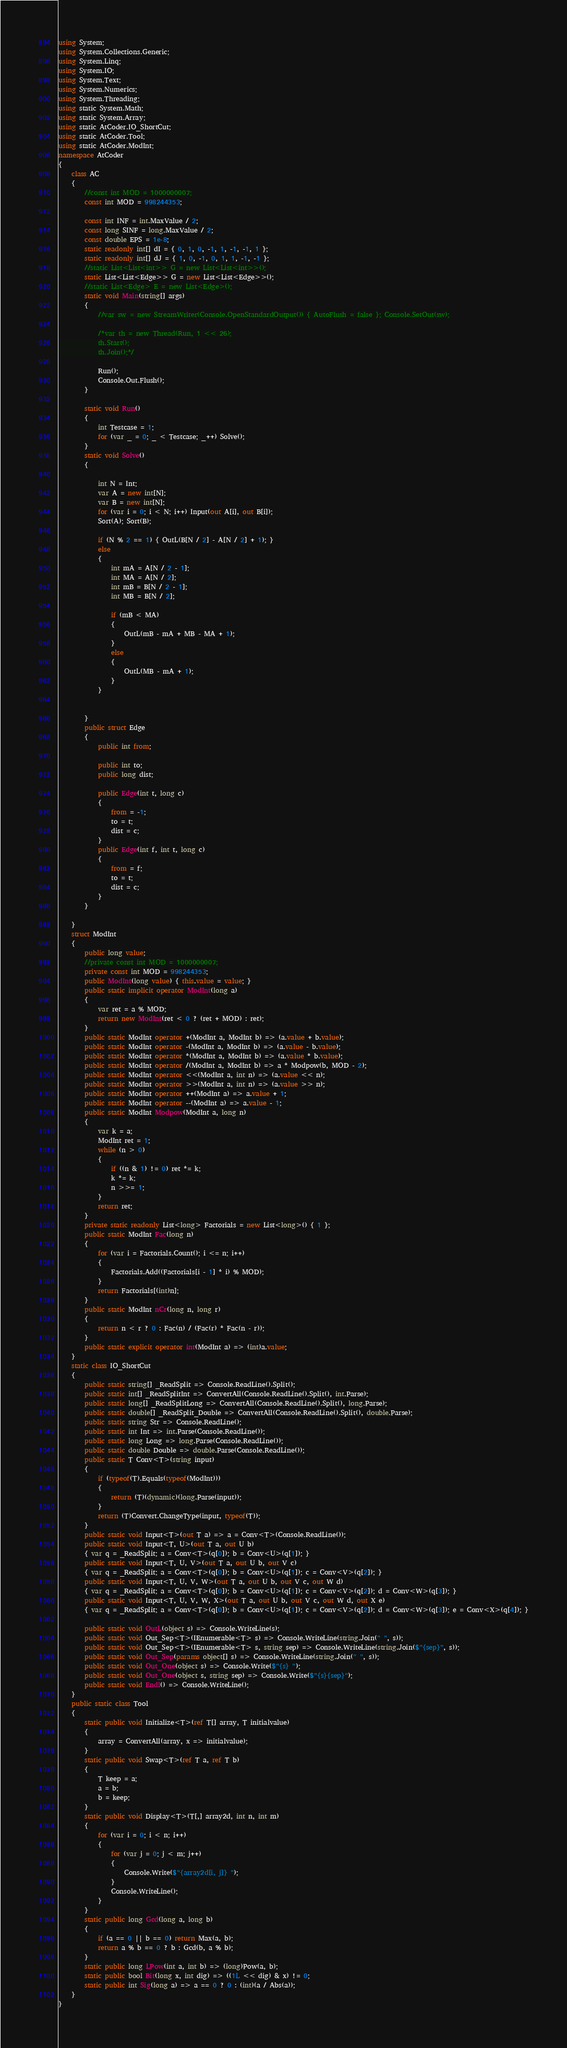<code> <loc_0><loc_0><loc_500><loc_500><_C#_>using System;
using System.Collections.Generic;
using System.Linq;
using System.IO;
using System.Text;
using System.Numerics;
using System.Threading;
using static System.Math;
using static System.Array;
using static AtCoder.IO_ShortCut;
using static AtCoder.Tool;
using static AtCoder.ModInt;
namespace AtCoder
{
    class AC
    {
        //const int MOD = 1000000007;
        const int MOD = 998244353;

        const int INF = int.MaxValue / 2;
        const long SINF = long.MaxValue / 2;
        const double EPS = 1e-8;
        static readonly int[] dI = { 0, 1, 0, -1, 1, -1, -1, 1 };
        static readonly int[] dJ = { 1, 0, -1, 0, 1, 1, -1, -1 };
        //static List<List<int>> G = new List<List<int>>();
        static List<List<Edge>> G = new List<List<Edge>>();
        //static List<Edge> E = new List<Edge>();
        static void Main(string[] args)
        {
            //var sw = new StreamWriter(Console.OpenStandardOutput()) { AutoFlush = false }; Console.SetOut(sw);

            /*var th = new Thread(Run, 1 << 26);
            th.Start();
            th.Join();*/

            Run();
            Console.Out.Flush();
        }

        static void Run()
        {
            int Testcase = 1;
            for (var _ = 0; _ < Testcase; _++) Solve();
        }
        static void Solve()
        {

            int N = Int;
            var A = new int[N];
            var B = new int[N];
            for (var i = 0; i < N; i++) Input(out A[i], out B[i]);
            Sort(A); Sort(B);

            if (N % 2 == 1) { OutL(B[N / 2] - A[N / 2] + 1); }
            else
            {
                int mA = A[N / 2 - 1];
                int MA = A[N / 2];
                int mB = B[N / 2 - 1];
                int MB = B[N / 2];

                if (mB < MA)
                {
                    OutL(mB - mA + MB - MA + 1);
                }
                else
                {
                    OutL(MB - mA + 1);
                }
            }


        }
        public struct Edge
        {
            public int from;

            public int to;
            public long dist;

            public Edge(int t, long c)
            {
                from = -1;
                to = t;
                dist = c;
            }
            public Edge(int f, int t, long c)
            {
                from = f;
                to = t;
                dist = c;
            }
        }
        
    }
    struct ModInt
    {
        public long value;
        //private const int MOD = 1000000007;
        private const int MOD = 998244353;
        public ModInt(long value) { this.value = value; }
        public static implicit operator ModInt(long a)
        {
            var ret = a % MOD;
            return new ModInt(ret < 0 ? (ret + MOD) : ret);
        }
        public static ModInt operator +(ModInt a, ModInt b) => (a.value + b.value);
        public static ModInt operator -(ModInt a, ModInt b) => (a.value - b.value);
        public static ModInt operator *(ModInt a, ModInt b) => (a.value * b.value);
        public static ModInt operator /(ModInt a, ModInt b) => a * Modpow(b, MOD - 2);
        public static ModInt operator <<(ModInt a, int n) => (a.value << n);
        public static ModInt operator >>(ModInt a, int n) => (a.value >> n);
        public static ModInt operator ++(ModInt a) => a.value + 1;
        public static ModInt operator --(ModInt a) => a.value - 1;
        public static ModInt Modpow(ModInt a, long n)
        {
            var k = a;
            ModInt ret = 1;
            while (n > 0)
            {
                if ((n & 1) != 0) ret *= k;
                k *= k;
                n >>= 1;
            }
            return ret;
        }
        private static readonly List<long> Factorials = new List<long>() { 1 };
        public static ModInt Fac(long n)
        {
            for (var i = Factorials.Count(); i <= n; i++)
            {
                Factorials.Add((Factorials[i - 1] * i) % MOD);
            }
            return Factorials[(int)n];
        }
        public static ModInt nCr(long n, long r)
        {
            return n < r ? 0 : Fac(n) / (Fac(r) * Fac(n - r));
        }
        public static explicit operator int(ModInt a) => (int)a.value;
    }
    static class IO_ShortCut
    {
        public static string[] _ReadSplit => Console.ReadLine().Split();
        public static int[] _ReadSplitInt => ConvertAll(Console.ReadLine().Split(), int.Parse);
        public static long[] _ReadSplitLong => ConvertAll(Console.ReadLine().Split(), long.Parse);
        public static double[] _ReadSplit_Double => ConvertAll(Console.ReadLine().Split(), double.Parse);
        public static string Str => Console.ReadLine();
        public static int Int => int.Parse(Console.ReadLine());
        public static long Long => long.Parse(Console.ReadLine());
        public static double Double => double.Parse(Console.ReadLine());
        public static T Conv<T>(string input)
        {
            if (typeof(T).Equals(typeof(ModInt)))
            {
                return (T)(dynamic)(long.Parse(input));
            }
            return (T)Convert.ChangeType(input, typeof(T));
        }
        public static void Input<T>(out T a) => a = Conv<T>(Console.ReadLine());
        public static void Input<T, U>(out T a, out U b)
        { var q = _ReadSplit; a = Conv<T>(q[0]); b = Conv<U>(q[1]); }
        public static void Input<T, U, V>(out T a, out U b, out V c)
        { var q = _ReadSplit; a = Conv<T>(q[0]); b = Conv<U>(q[1]); c = Conv<V>(q[2]); }
        public static void Input<T, U, V, W>(out T a, out U b, out V c, out W d)
        { var q = _ReadSplit; a = Conv<T>(q[0]); b = Conv<U>(q[1]); c = Conv<V>(q[2]); d = Conv<W>(q[3]); }
        public static void Input<T, U, V, W, X>(out T a, out U b, out V c, out W d, out X e)
        { var q = _ReadSplit; a = Conv<T>(q[0]); b = Conv<U>(q[1]); c = Conv<V>(q[2]); d = Conv<W>(q[3]); e = Conv<X>(q[4]); }

        public static void OutL(object s) => Console.WriteLine(s);
        public static void Out_Sep<T>(IEnumerable<T> s) => Console.WriteLine(string.Join(" ", s));
        public static void Out_Sep<T>(IEnumerable<T> s, string sep) => Console.WriteLine(string.Join($"{sep}", s));
        public static void Out_Sep(params object[] s) => Console.WriteLine(string.Join(" ", s));
        public static void Out_One(object s) => Console.Write($"{s} ");
        public static void Out_One(object s, string sep) => Console.Write($"{s}{sep}");
        public static void Endl() => Console.WriteLine();
    }
    public static class Tool
    {
        static public void Initialize<T>(ref T[] array, T initialvalue)
        {
            array = ConvertAll(array, x => initialvalue);
        }
        static public void Swap<T>(ref T a, ref T b)
        {
            T keep = a;
            a = b;
            b = keep;
        }
        static public void Display<T>(T[,] array2d, int n, int m)
        {
            for (var i = 0; i < n; i++)
            {
                for (var j = 0; j < m; j++)
                {
                    Console.Write($"{array2d[i, j]} ");
                }
                Console.WriteLine();
            }
        }
        static public long Gcd(long a, long b)
        {
            if (a == 0 || b == 0) return Max(a, b);
            return a % b == 0 ? b : Gcd(b, a % b);
        }
        static public long LPow(int a, int b) => (long)Pow(a, b);
        static public bool Bit(long x, int dig) => ((1L << dig) & x) != 0;
        static public int Sig(long a) => a == 0 ? 0 : (int)(a / Abs(a));
    }
}
</code> 